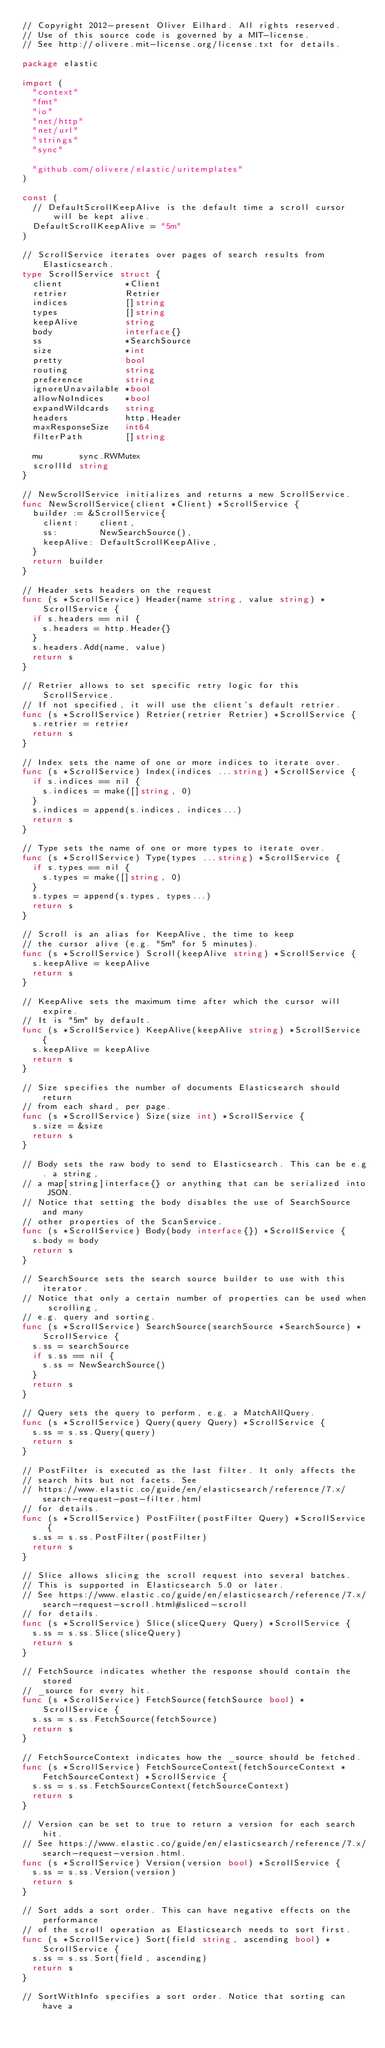Convert code to text. <code><loc_0><loc_0><loc_500><loc_500><_Go_>// Copyright 2012-present Oliver Eilhard. All rights reserved.
// Use of this source code is governed by a MIT-license.
// See http://olivere.mit-license.org/license.txt for details.

package elastic

import (
	"context"
	"fmt"
	"io"
	"net/http"
	"net/url"
	"strings"
	"sync"

	"github.com/olivere/elastic/uritemplates"
)

const (
	// DefaultScrollKeepAlive is the default time a scroll cursor will be kept alive.
	DefaultScrollKeepAlive = "5m"
)

// ScrollService iterates over pages of search results from Elasticsearch.
type ScrollService struct {
	client            *Client
	retrier           Retrier
	indices           []string
	types             []string
	keepAlive         string
	body              interface{}
	ss                *SearchSource
	size              *int
	pretty            bool
	routing           string
	preference        string
	ignoreUnavailable *bool
	allowNoIndices    *bool
	expandWildcards   string
	headers           http.Header
	maxResponseSize   int64
	filterPath        []string

	mu       sync.RWMutex
	scrollId string
}

// NewScrollService initializes and returns a new ScrollService.
func NewScrollService(client *Client) *ScrollService {
	builder := &ScrollService{
		client:    client,
		ss:        NewSearchSource(),
		keepAlive: DefaultScrollKeepAlive,
	}
	return builder
}

// Header sets headers on the request
func (s *ScrollService) Header(name string, value string) *ScrollService {
	if s.headers == nil {
		s.headers = http.Header{}
	}
	s.headers.Add(name, value)
	return s
}

// Retrier allows to set specific retry logic for this ScrollService.
// If not specified, it will use the client's default retrier.
func (s *ScrollService) Retrier(retrier Retrier) *ScrollService {
	s.retrier = retrier
	return s
}

// Index sets the name of one or more indices to iterate over.
func (s *ScrollService) Index(indices ...string) *ScrollService {
	if s.indices == nil {
		s.indices = make([]string, 0)
	}
	s.indices = append(s.indices, indices...)
	return s
}

// Type sets the name of one or more types to iterate over.
func (s *ScrollService) Type(types ...string) *ScrollService {
	if s.types == nil {
		s.types = make([]string, 0)
	}
	s.types = append(s.types, types...)
	return s
}

// Scroll is an alias for KeepAlive, the time to keep
// the cursor alive (e.g. "5m" for 5 minutes).
func (s *ScrollService) Scroll(keepAlive string) *ScrollService {
	s.keepAlive = keepAlive
	return s
}

// KeepAlive sets the maximum time after which the cursor will expire.
// It is "5m" by default.
func (s *ScrollService) KeepAlive(keepAlive string) *ScrollService {
	s.keepAlive = keepAlive
	return s
}

// Size specifies the number of documents Elasticsearch should return
// from each shard, per page.
func (s *ScrollService) Size(size int) *ScrollService {
	s.size = &size
	return s
}

// Body sets the raw body to send to Elasticsearch. This can be e.g. a string,
// a map[string]interface{} or anything that can be serialized into JSON.
// Notice that setting the body disables the use of SearchSource and many
// other properties of the ScanService.
func (s *ScrollService) Body(body interface{}) *ScrollService {
	s.body = body
	return s
}

// SearchSource sets the search source builder to use with this iterator.
// Notice that only a certain number of properties can be used when scrolling,
// e.g. query and sorting.
func (s *ScrollService) SearchSource(searchSource *SearchSource) *ScrollService {
	s.ss = searchSource
	if s.ss == nil {
		s.ss = NewSearchSource()
	}
	return s
}

// Query sets the query to perform, e.g. a MatchAllQuery.
func (s *ScrollService) Query(query Query) *ScrollService {
	s.ss = s.ss.Query(query)
	return s
}

// PostFilter is executed as the last filter. It only affects the
// search hits but not facets. See
// https://www.elastic.co/guide/en/elasticsearch/reference/7.x/search-request-post-filter.html
// for details.
func (s *ScrollService) PostFilter(postFilter Query) *ScrollService {
	s.ss = s.ss.PostFilter(postFilter)
	return s
}

// Slice allows slicing the scroll request into several batches.
// This is supported in Elasticsearch 5.0 or later.
// See https://www.elastic.co/guide/en/elasticsearch/reference/7.x/search-request-scroll.html#sliced-scroll
// for details.
func (s *ScrollService) Slice(sliceQuery Query) *ScrollService {
	s.ss = s.ss.Slice(sliceQuery)
	return s
}

// FetchSource indicates whether the response should contain the stored
// _source for every hit.
func (s *ScrollService) FetchSource(fetchSource bool) *ScrollService {
	s.ss = s.ss.FetchSource(fetchSource)
	return s
}

// FetchSourceContext indicates how the _source should be fetched.
func (s *ScrollService) FetchSourceContext(fetchSourceContext *FetchSourceContext) *ScrollService {
	s.ss = s.ss.FetchSourceContext(fetchSourceContext)
	return s
}

// Version can be set to true to return a version for each search hit.
// See https://www.elastic.co/guide/en/elasticsearch/reference/7.x/search-request-version.html.
func (s *ScrollService) Version(version bool) *ScrollService {
	s.ss = s.ss.Version(version)
	return s
}

// Sort adds a sort order. This can have negative effects on the performance
// of the scroll operation as Elasticsearch needs to sort first.
func (s *ScrollService) Sort(field string, ascending bool) *ScrollService {
	s.ss = s.ss.Sort(field, ascending)
	return s
}

// SortWithInfo specifies a sort order. Notice that sorting can have a</code> 